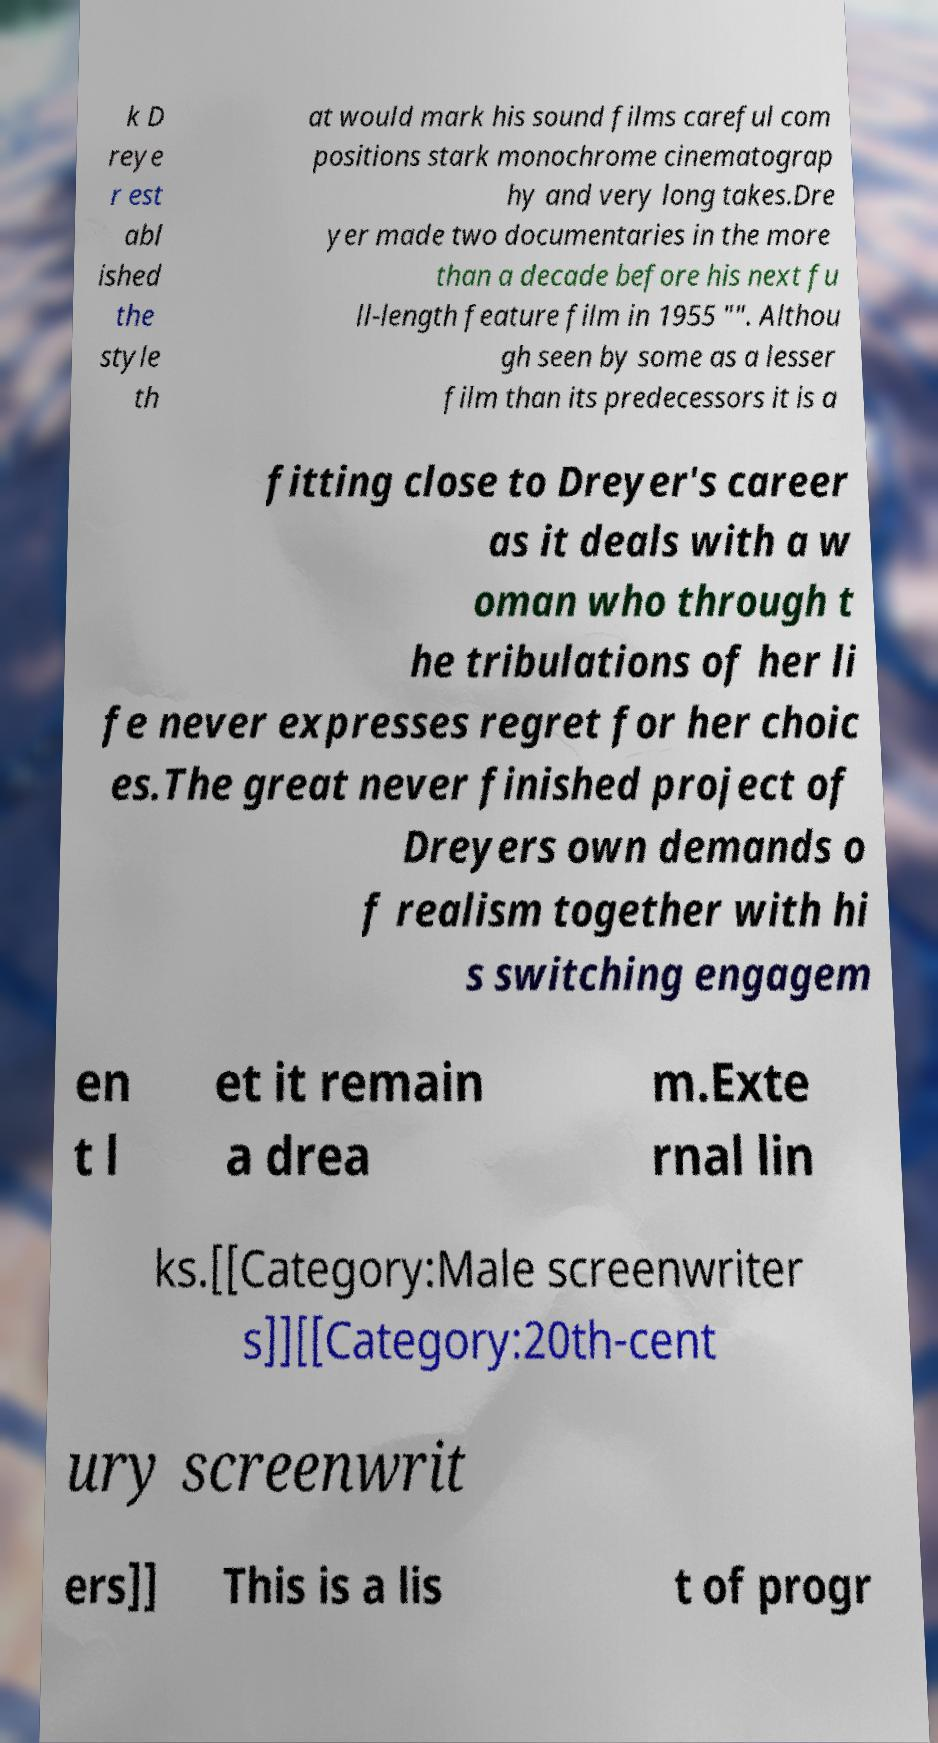What messages or text are displayed in this image? I need them in a readable, typed format. k D reye r est abl ished the style th at would mark his sound films careful com positions stark monochrome cinematograp hy and very long takes.Dre yer made two documentaries in the more than a decade before his next fu ll-length feature film in 1955 "". Althou gh seen by some as a lesser film than its predecessors it is a fitting close to Dreyer's career as it deals with a w oman who through t he tribulations of her li fe never expresses regret for her choic es.The great never finished project of Dreyers own demands o f realism together with hi s switching engagem en t l et it remain a drea m.Exte rnal lin ks.[[Category:Male screenwriter s]][[Category:20th-cent ury screenwrit ers]] This is a lis t of progr 